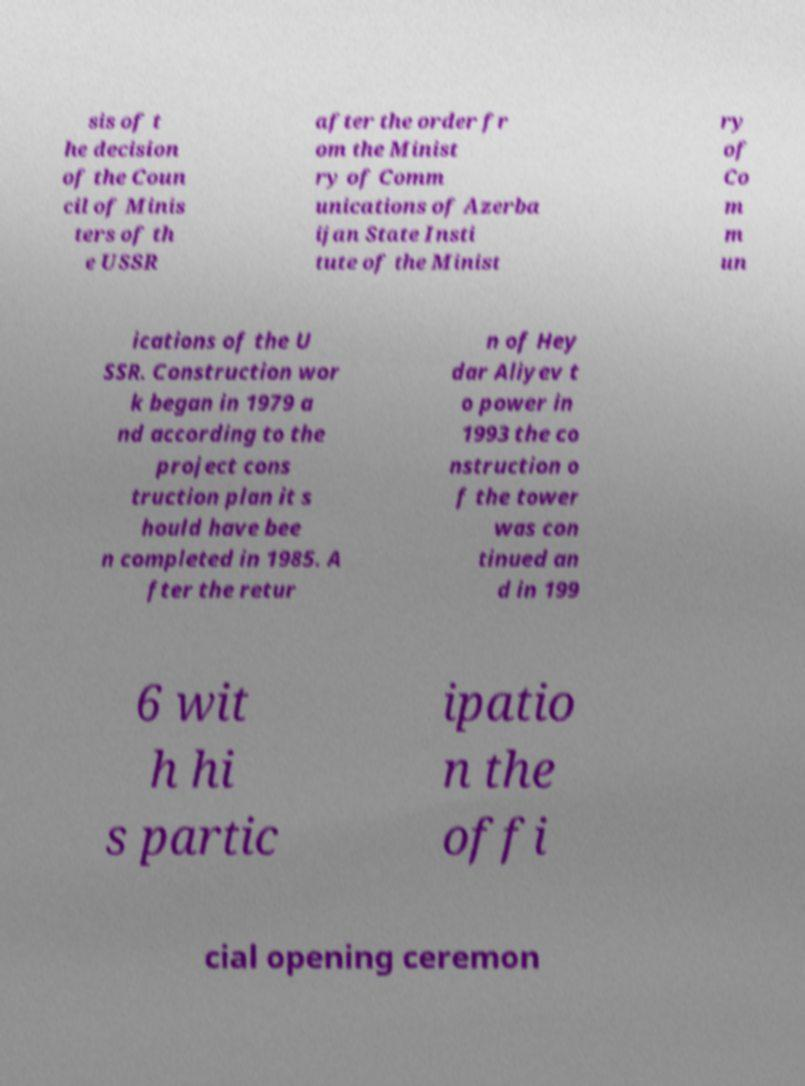Could you assist in decoding the text presented in this image and type it out clearly? sis of t he decision of the Coun cil of Minis ters of th e USSR after the order fr om the Minist ry of Comm unications of Azerba ijan State Insti tute of the Minist ry of Co m m un ications of the U SSR. Construction wor k began in 1979 a nd according to the project cons truction plan it s hould have bee n completed in 1985. A fter the retur n of Hey dar Aliyev t o power in 1993 the co nstruction o f the tower was con tinued an d in 199 6 wit h hi s partic ipatio n the offi cial opening ceremon 